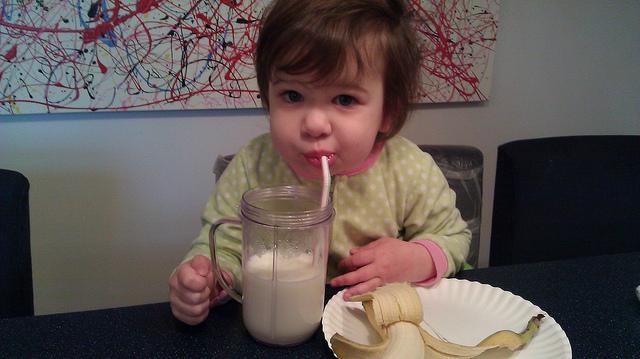What type of skin peel is on the table?
Give a very brief answer. Banana. What color is the straw?
Concise answer only. White. What is the baby holding?
Concise answer only. Plate. Is the milk organic?
Answer briefly. No. What is the child eating?
Give a very brief answer. Banana. What fruit is on the paper plate?
Concise answer only. Banana. What does her meal consist of?
Give a very brief answer. Banana. Is that a keyboard  in the background?
Be succinct. No. What color is the baby's hair?
Quick response, please. Brown. Is this a lot of food for the girl?
Be succinct. No. What is the baby eating in the pic?
Quick response, please. Banana. Where is the straw?
Keep it brief. In cup. What is the baby licking off his fingers?
Be succinct. Banana. What does this child have in her hands?
Quick response, please. Nothing. What is the girl eating?
Be succinct. Banana. What color is the liquid in the cup?
Be succinct. White. Is this a Chinese plate?
Write a very short answer. No. Is this a good meal for nutrition?
Quick response, please. Yes. What is she drinking?
Concise answer only. Milk. What color are her eyes?
Give a very brief answer. Brown. Is this boy drinking choco milk?
Short answer required. No. What is the baby going to do?
Give a very brief answer. Drink. Is that orange juice?
Write a very short answer. No. What type of liquid is most likely in the cup served with this type of food?
Be succinct. Milk. How many kids are there?
Write a very short answer. 1. What kind of tasting is this?
Short answer required. Milk. What color is the table?
Give a very brief answer. Black. 